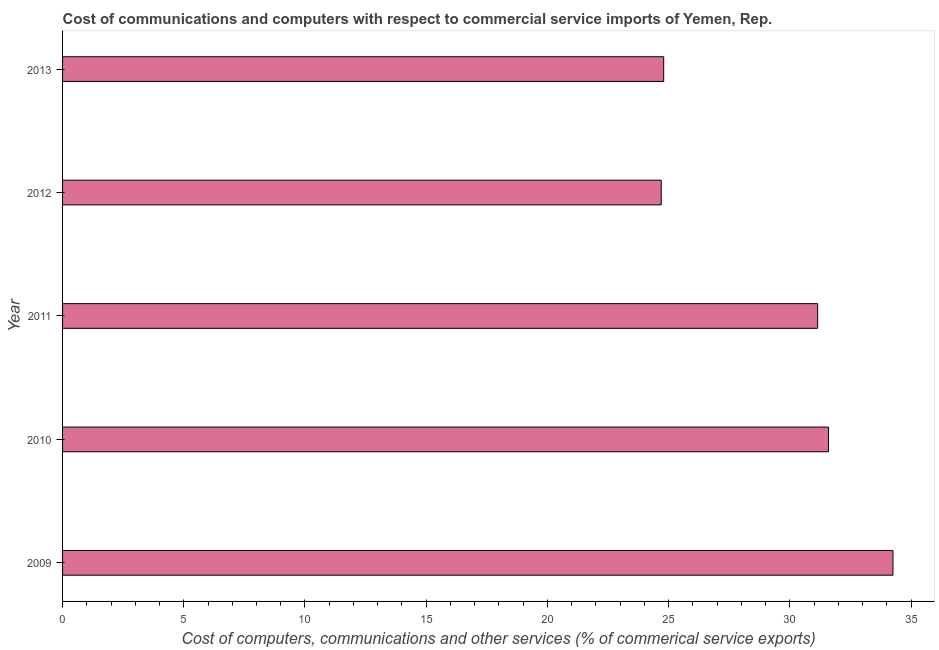Does the graph contain grids?
Your answer should be compact. No. What is the title of the graph?
Make the answer very short. Cost of communications and computers with respect to commercial service imports of Yemen, Rep. What is the label or title of the X-axis?
Provide a succinct answer. Cost of computers, communications and other services (% of commerical service exports). What is the cost of communications in 2012?
Your answer should be compact. 24.7. Across all years, what is the maximum  computer and other services?
Your answer should be compact. 34.26. Across all years, what is the minimum cost of communications?
Offer a terse response. 24.7. In which year was the cost of communications minimum?
Your answer should be very brief. 2012. What is the sum of the  computer and other services?
Offer a terse response. 146.49. What is the difference between the  computer and other services in 2010 and 2013?
Give a very brief answer. 6.8. What is the average  computer and other services per year?
Your answer should be very brief. 29.3. What is the median cost of communications?
Your answer should be very brief. 31.15. What is the ratio of the  computer and other services in 2009 to that in 2012?
Offer a terse response. 1.39. Is the  computer and other services in 2009 less than that in 2011?
Your answer should be very brief. No. What is the difference between the highest and the second highest cost of communications?
Ensure brevity in your answer.  2.66. Is the sum of the  computer and other services in 2009 and 2011 greater than the maximum  computer and other services across all years?
Your answer should be compact. Yes. What is the difference between the highest and the lowest cost of communications?
Make the answer very short. 9.56. Are all the bars in the graph horizontal?
Your response must be concise. Yes. What is the Cost of computers, communications and other services (% of commerical service exports) in 2009?
Your answer should be compact. 34.26. What is the Cost of computers, communications and other services (% of commerical service exports) of 2010?
Provide a succinct answer. 31.6. What is the Cost of computers, communications and other services (% of commerical service exports) of 2011?
Offer a very short reply. 31.15. What is the Cost of computers, communications and other services (% of commerical service exports) in 2012?
Your answer should be very brief. 24.7. What is the Cost of computers, communications and other services (% of commerical service exports) in 2013?
Give a very brief answer. 24.8. What is the difference between the Cost of computers, communications and other services (% of commerical service exports) in 2009 and 2010?
Your response must be concise. 2.66. What is the difference between the Cost of computers, communications and other services (% of commerical service exports) in 2009 and 2011?
Offer a terse response. 3.11. What is the difference between the Cost of computers, communications and other services (% of commerical service exports) in 2009 and 2012?
Provide a succinct answer. 9.56. What is the difference between the Cost of computers, communications and other services (% of commerical service exports) in 2009 and 2013?
Give a very brief answer. 9.46. What is the difference between the Cost of computers, communications and other services (% of commerical service exports) in 2010 and 2011?
Your answer should be compact. 0.45. What is the difference between the Cost of computers, communications and other services (% of commerical service exports) in 2010 and 2012?
Your answer should be very brief. 6.9. What is the difference between the Cost of computers, communications and other services (% of commerical service exports) in 2010 and 2013?
Your answer should be very brief. 6.8. What is the difference between the Cost of computers, communications and other services (% of commerical service exports) in 2011 and 2012?
Provide a short and direct response. 6.45. What is the difference between the Cost of computers, communications and other services (% of commerical service exports) in 2011 and 2013?
Your answer should be very brief. 6.35. What is the difference between the Cost of computers, communications and other services (% of commerical service exports) in 2012 and 2013?
Ensure brevity in your answer.  -0.1. What is the ratio of the Cost of computers, communications and other services (% of commerical service exports) in 2009 to that in 2010?
Make the answer very short. 1.08. What is the ratio of the Cost of computers, communications and other services (% of commerical service exports) in 2009 to that in 2012?
Offer a very short reply. 1.39. What is the ratio of the Cost of computers, communications and other services (% of commerical service exports) in 2009 to that in 2013?
Offer a very short reply. 1.38. What is the ratio of the Cost of computers, communications and other services (% of commerical service exports) in 2010 to that in 2012?
Offer a very short reply. 1.28. What is the ratio of the Cost of computers, communications and other services (% of commerical service exports) in 2010 to that in 2013?
Keep it short and to the point. 1.27. What is the ratio of the Cost of computers, communications and other services (% of commerical service exports) in 2011 to that in 2012?
Your response must be concise. 1.26. What is the ratio of the Cost of computers, communications and other services (% of commerical service exports) in 2011 to that in 2013?
Your answer should be very brief. 1.26. What is the ratio of the Cost of computers, communications and other services (% of commerical service exports) in 2012 to that in 2013?
Your answer should be compact. 1. 